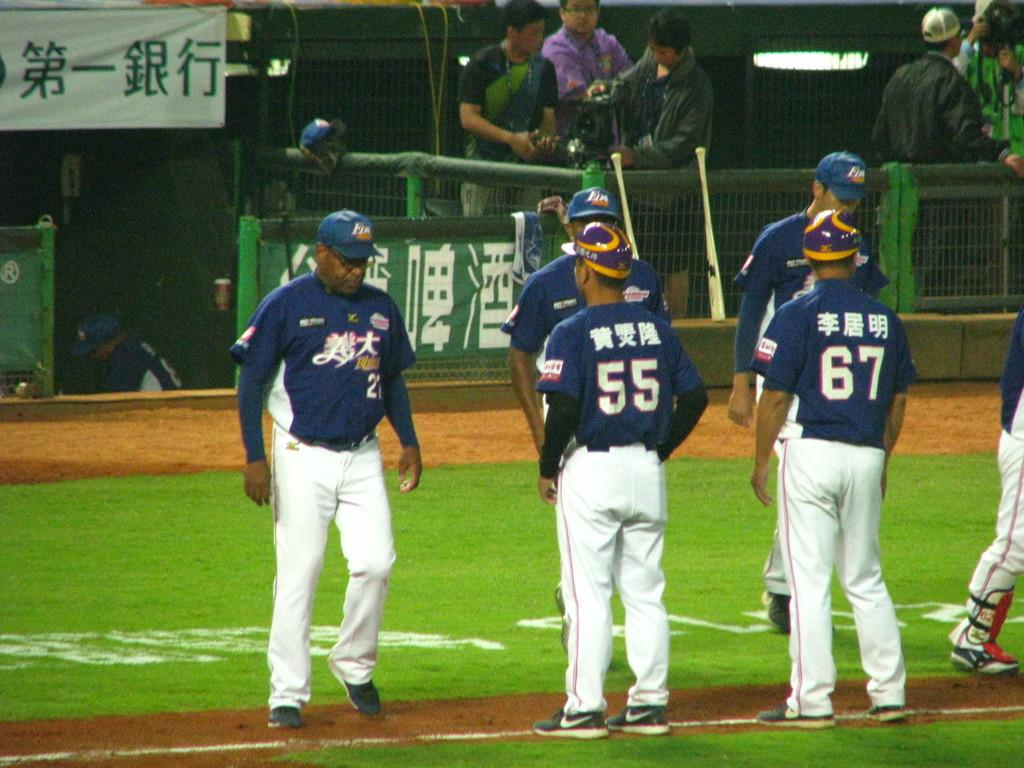<image>
Provide a brief description of the given image. A group of Japanese baseball players stand on the field, the numbers 55 and 67 are visible on their backs. 